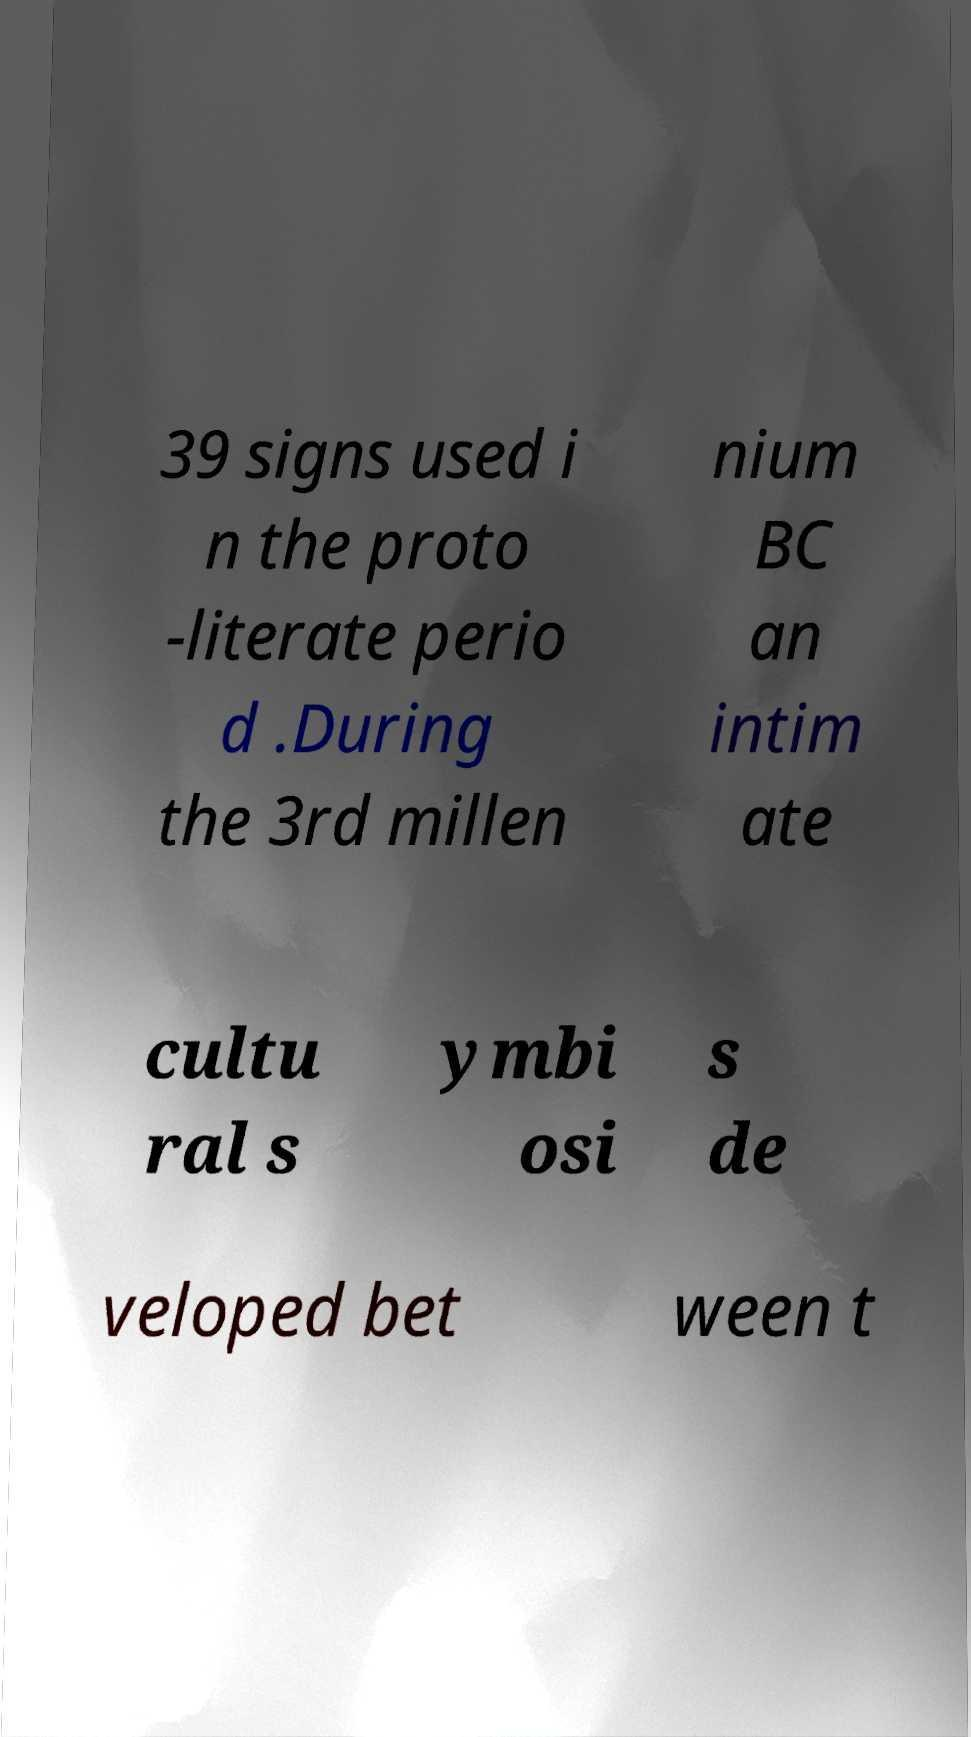Please identify and transcribe the text found in this image. 39 signs used i n the proto -literate perio d .During the 3rd millen nium BC an intim ate cultu ral s ymbi osi s de veloped bet ween t 